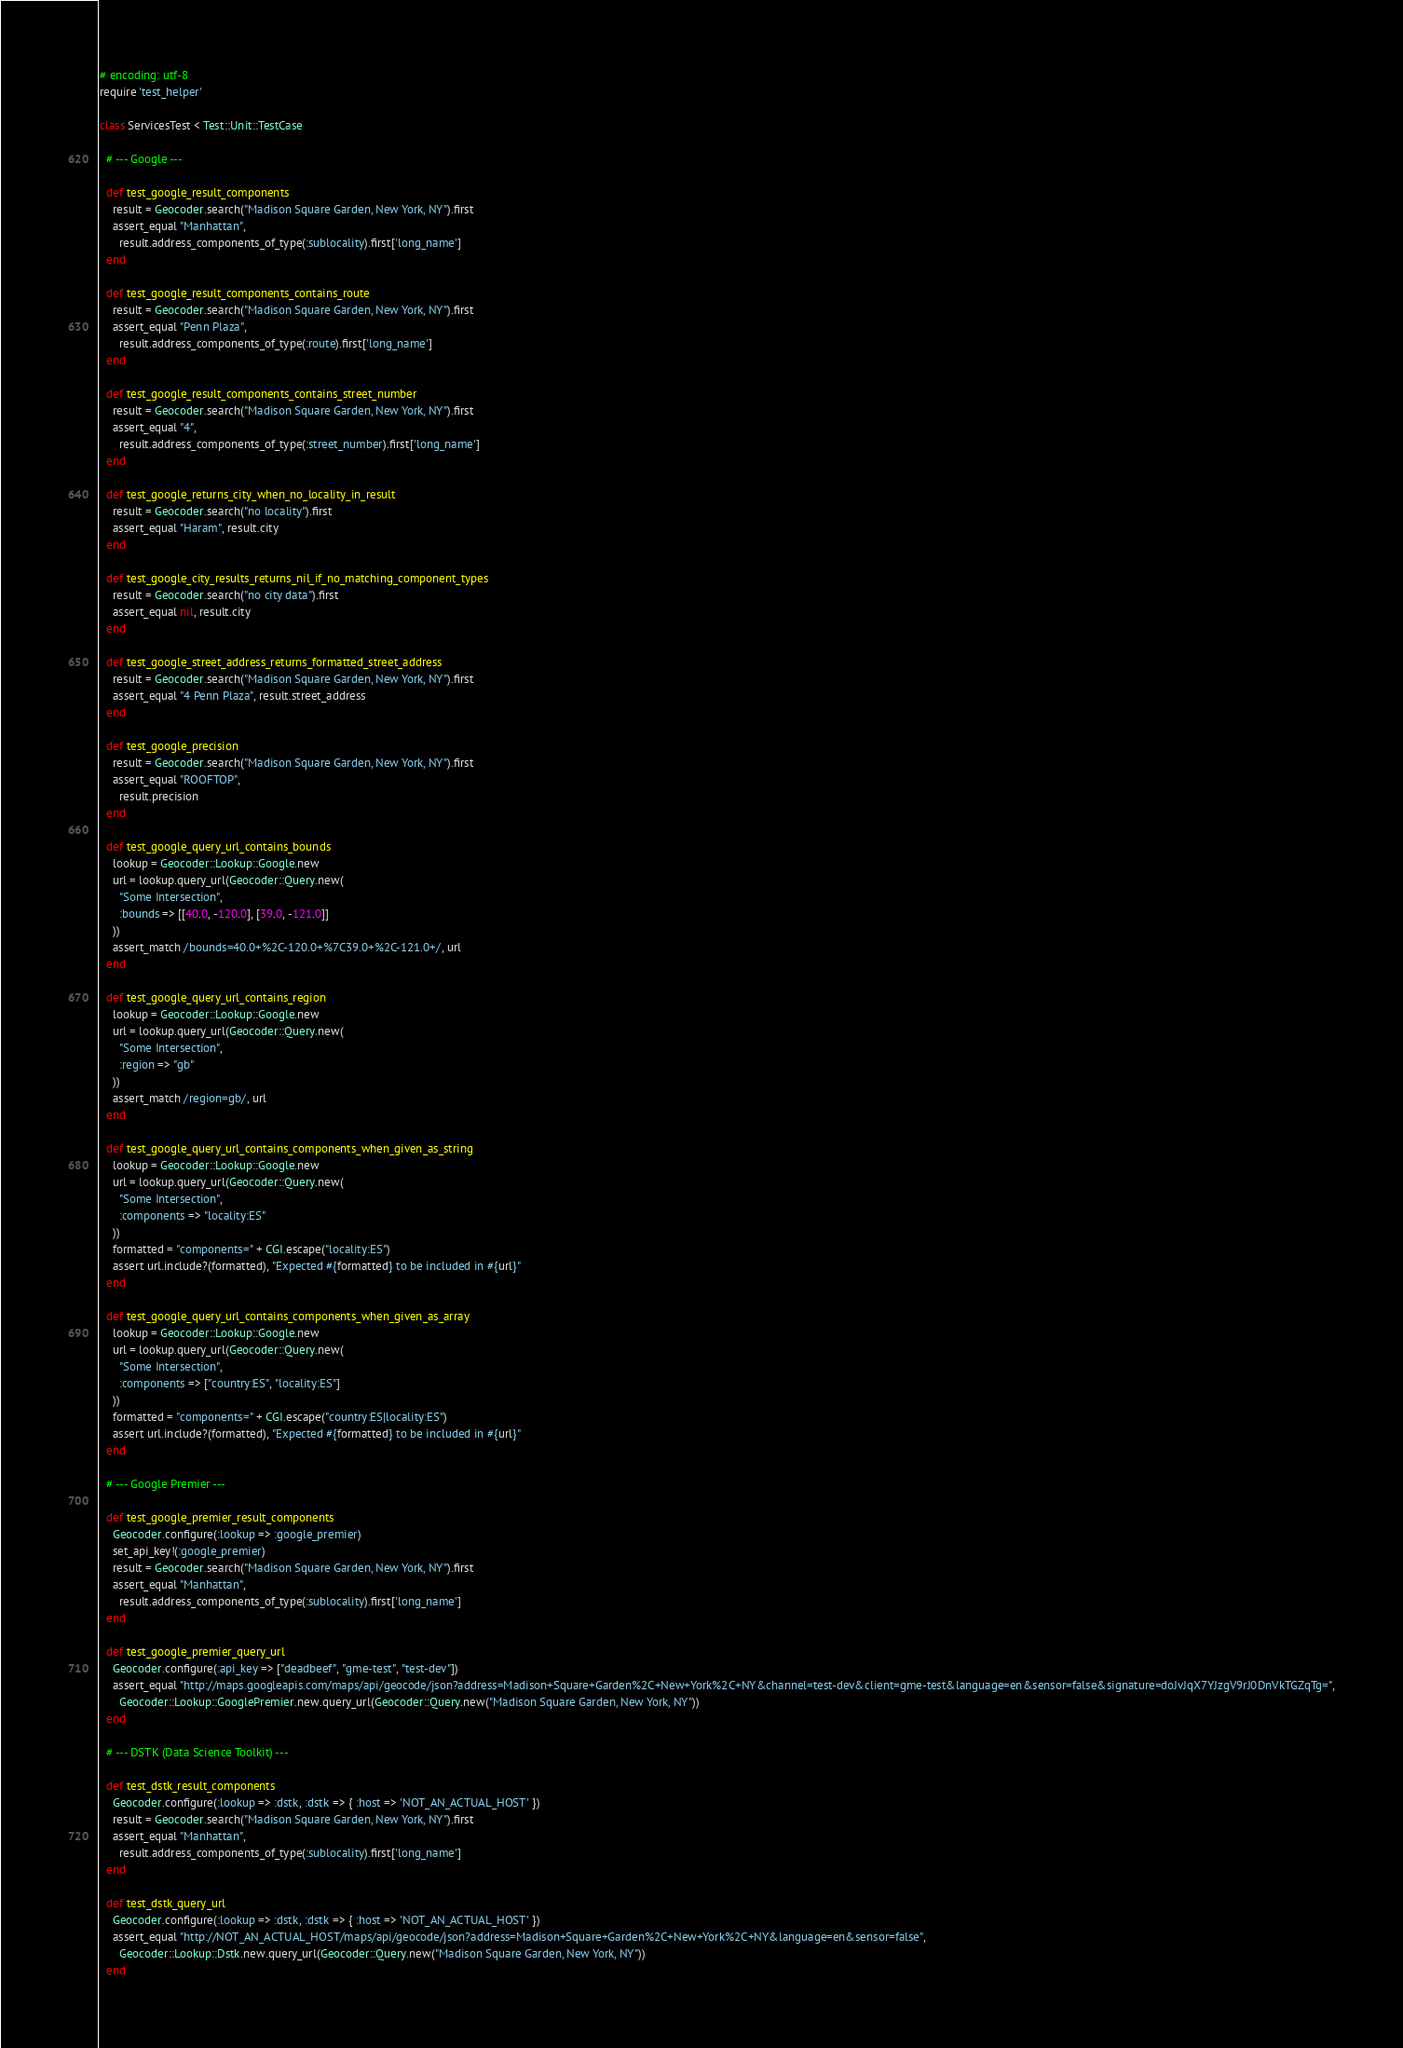<code> <loc_0><loc_0><loc_500><loc_500><_Ruby_># encoding: utf-8
require 'test_helper'

class ServicesTest < Test::Unit::TestCase

  # --- Google ---

  def test_google_result_components
    result = Geocoder.search("Madison Square Garden, New York, NY").first
    assert_equal "Manhattan",
      result.address_components_of_type(:sublocality).first['long_name']
  end

  def test_google_result_components_contains_route
    result = Geocoder.search("Madison Square Garden, New York, NY").first
    assert_equal "Penn Plaza",
      result.address_components_of_type(:route).first['long_name']
  end

  def test_google_result_components_contains_street_number
    result = Geocoder.search("Madison Square Garden, New York, NY").first
    assert_equal "4",
      result.address_components_of_type(:street_number).first['long_name']
  end

  def test_google_returns_city_when_no_locality_in_result
    result = Geocoder.search("no locality").first
    assert_equal "Haram", result.city
  end

  def test_google_city_results_returns_nil_if_no_matching_component_types
    result = Geocoder.search("no city data").first
    assert_equal nil, result.city
  end

  def test_google_street_address_returns_formatted_street_address
    result = Geocoder.search("Madison Square Garden, New York, NY").first
    assert_equal "4 Penn Plaza", result.street_address
  end

  def test_google_precision
    result = Geocoder.search("Madison Square Garden, New York, NY").first
    assert_equal "ROOFTOP",
      result.precision
  end

  def test_google_query_url_contains_bounds
    lookup = Geocoder::Lookup::Google.new
    url = lookup.query_url(Geocoder::Query.new(
      "Some Intersection",
      :bounds => [[40.0, -120.0], [39.0, -121.0]]
    ))
    assert_match /bounds=40.0+%2C-120.0+%7C39.0+%2C-121.0+/, url
  end

  def test_google_query_url_contains_region
    lookup = Geocoder::Lookup::Google.new
    url = lookup.query_url(Geocoder::Query.new(
      "Some Intersection",
      :region => "gb"
    ))
    assert_match /region=gb/, url
  end

  def test_google_query_url_contains_components_when_given_as_string
    lookup = Geocoder::Lookup::Google.new
    url = lookup.query_url(Geocoder::Query.new(
      "Some Intersection",
      :components => "locality:ES"
    ))
    formatted = "components=" + CGI.escape("locality:ES")
    assert url.include?(formatted), "Expected #{formatted} to be included in #{url}"
  end

  def test_google_query_url_contains_components_when_given_as_array
    lookup = Geocoder::Lookup::Google.new
    url = lookup.query_url(Geocoder::Query.new(
      "Some Intersection",
      :components => ["country:ES", "locality:ES"]
    ))
    formatted = "components=" + CGI.escape("country:ES|locality:ES")
    assert url.include?(formatted), "Expected #{formatted} to be included in #{url}"
  end

  # --- Google Premier ---

  def test_google_premier_result_components
    Geocoder.configure(:lookup => :google_premier)
    set_api_key!(:google_premier)
    result = Geocoder.search("Madison Square Garden, New York, NY").first
    assert_equal "Manhattan",
      result.address_components_of_type(:sublocality).first['long_name']
  end

  def test_google_premier_query_url
    Geocoder.configure(:api_key => ["deadbeef", "gme-test", "test-dev"])
    assert_equal "http://maps.googleapis.com/maps/api/geocode/json?address=Madison+Square+Garden%2C+New+York%2C+NY&channel=test-dev&client=gme-test&language=en&sensor=false&signature=doJvJqX7YJzgV9rJ0DnVkTGZqTg=",
      Geocoder::Lookup::GooglePremier.new.query_url(Geocoder::Query.new("Madison Square Garden, New York, NY"))
  end

  # --- DSTK (Data Science Toolkit) ---

  def test_dstk_result_components
    Geocoder.configure(:lookup => :dstk, :dstk => { :host => 'NOT_AN_ACTUAL_HOST' })
    result = Geocoder.search("Madison Square Garden, New York, NY").first
    assert_equal "Manhattan",
      result.address_components_of_type(:sublocality).first['long_name']
  end

  def test_dstk_query_url
    Geocoder.configure(:lookup => :dstk, :dstk => { :host => 'NOT_AN_ACTUAL_HOST' })
    assert_equal "http://NOT_AN_ACTUAL_HOST/maps/api/geocode/json?address=Madison+Square+Garden%2C+New+York%2C+NY&language=en&sensor=false",
      Geocoder::Lookup::Dstk.new.query_url(Geocoder::Query.new("Madison Square Garden, New York, NY"))
  end
</code> 